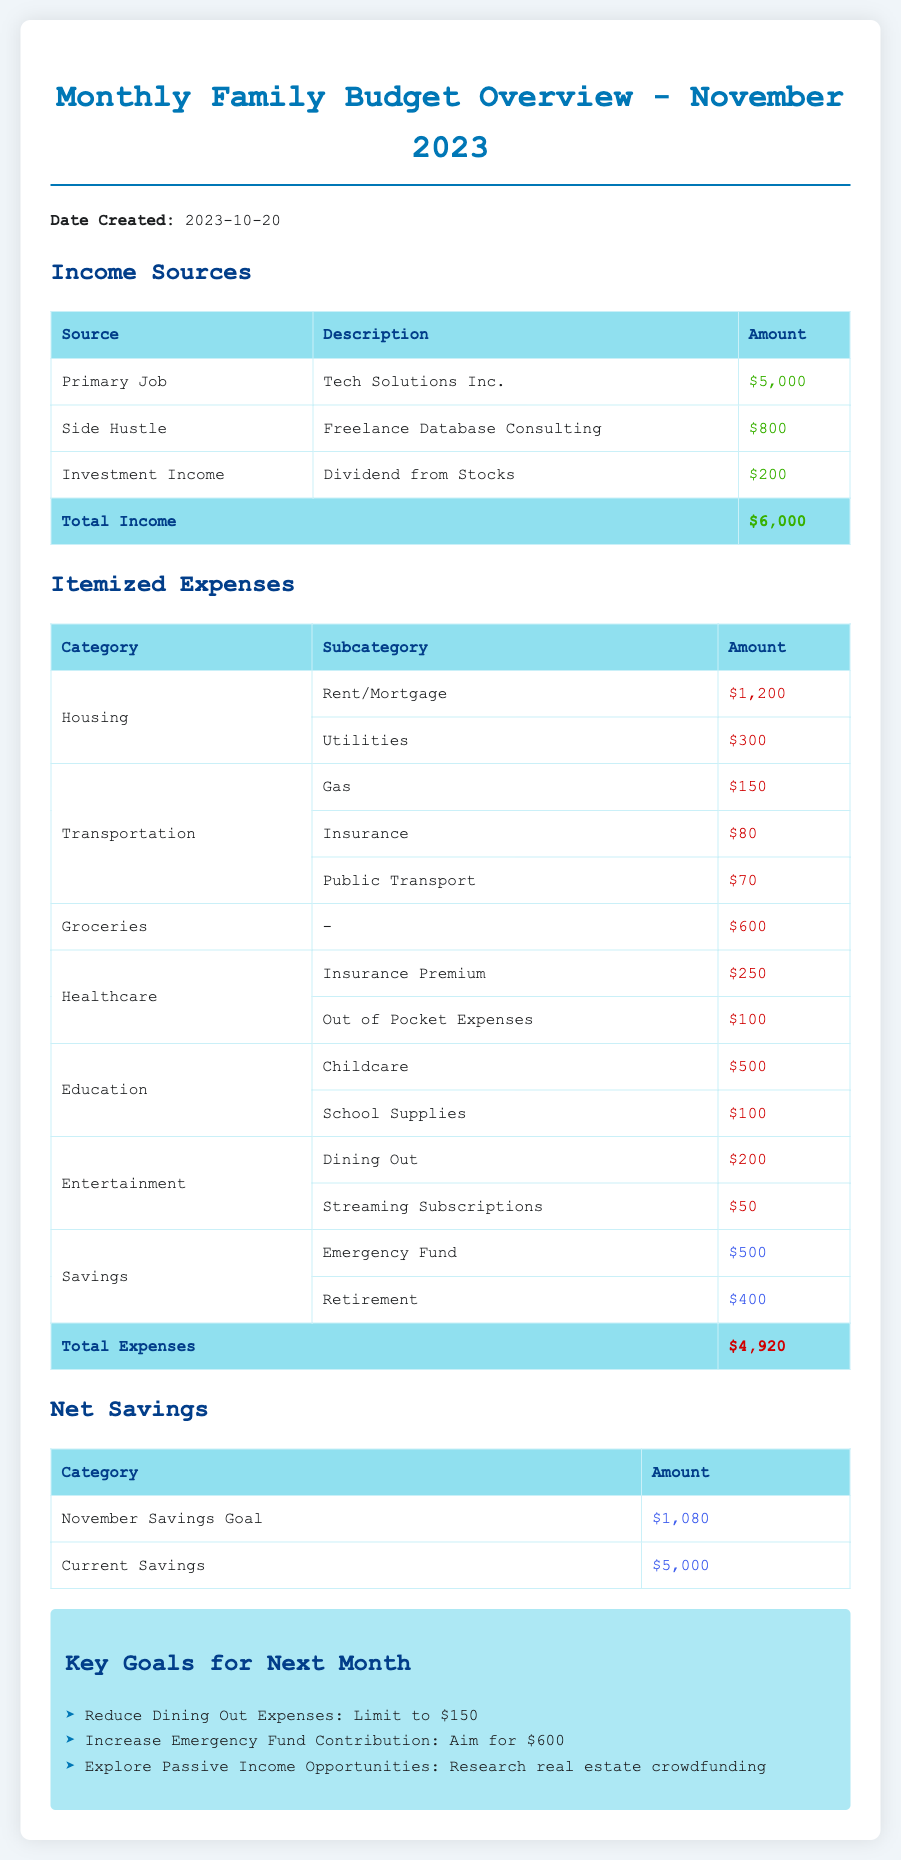What is the total income for November 2023? The total income is calculated by summing the amounts from all income sources listed in the document, which is $5,000 + $800 + $200 = $6,000.
Answer: $6,000 What is the total expenses amount? The total expenses are computed by adding all itemized expenses shown in the document, which totals to $4,920.
Answer: $4,920 What is the amount allocated for groceries? The document specifies that the expense for groceries is listed as $600.
Answer: $600 How much is contributed to the emergency fund? The document states that the contribution to the emergency fund is $500.
Answer: $500 What is the goal for the November savings? The document mentions that the November savings goal amounts to $1,080.
Answer: $1,080 Where does the primary job income come from? According to the document, the income from the primary job is sourced from Tech Solutions Inc.
Answer: Tech Solutions Inc How much is budgeted for dining out in the upcoming month? The document indicates that the budget for dining out is limited to $150.
Answer: $150 What is the total amount for retirement savings? The total amount allocated for retirement savings is specified as $400, as stated in the document.
Answer: $400 What is the date the budget overview was created? The document states that the budget overview was created on October 20, 2023.
Answer: 2023-10-20 